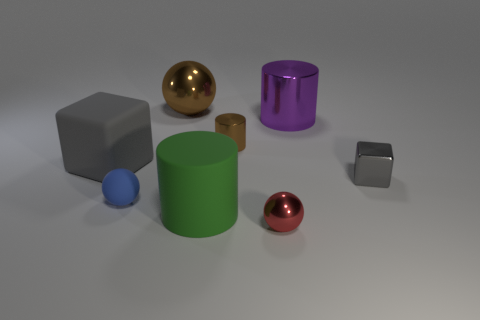Subtract all tiny spheres. How many spheres are left? 1 Subtract all purple cylinders. How many cylinders are left? 2 Subtract 1 cylinders. How many cylinders are left? 2 Add 2 tiny brown cylinders. How many objects exist? 10 Subtract all cylinders. How many objects are left? 5 Subtract all purple spheres. Subtract all yellow blocks. How many spheres are left? 3 Subtract all red cubes. How many blue cylinders are left? 0 Subtract all tiny red metal balls. Subtract all large cylinders. How many objects are left? 5 Add 6 small gray metal blocks. How many small gray metal blocks are left? 7 Add 1 large purple matte things. How many large purple matte things exist? 1 